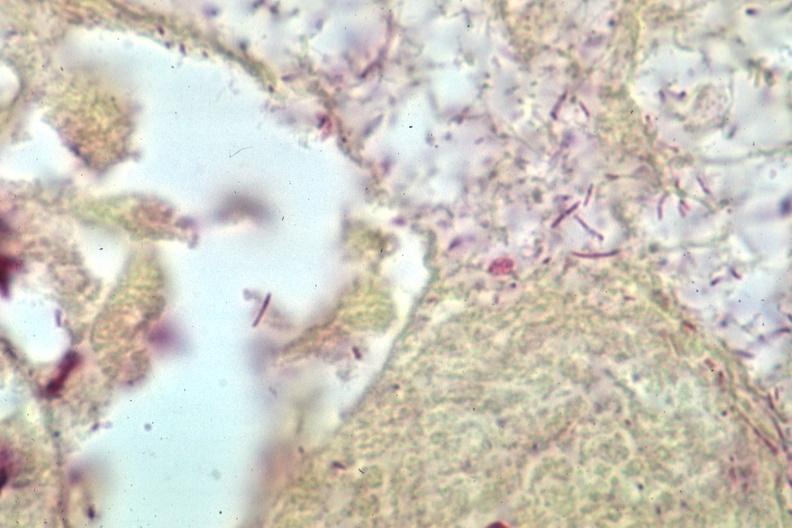s inflamed exocervix present?
Answer the question using a single word or phrase. No 